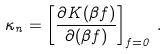Convert formula to latex. <formula><loc_0><loc_0><loc_500><loc_500>\kappa _ { n } = \left [ \frac { \partial K ( \beta f ) } { \partial ( \beta f ) } \right ] _ { f = 0 } \, .</formula> 